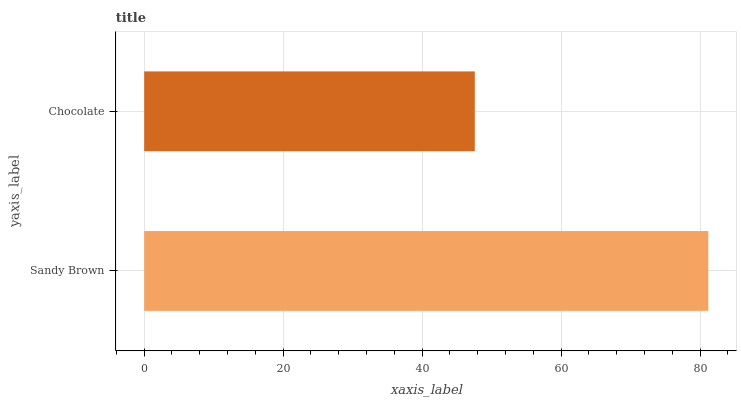Is Chocolate the minimum?
Answer yes or no. Yes. Is Sandy Brown the maximum?
Answer yes or no. Yes. Is Chocolate the maximum?
Answer yes or no. No. Is Sandy Brown greater than Chocolate?
Answer yes or no. Yes. Is Chocolate less than Sandy Brown?
Answer yes or no. Yes. Is Chocolate greater than Sandy Brown?
Answer yes or no. No. Is Sandy Brown less than Chocolate?
Answer yes or no. No. Is Sandy Brown the high median?
Answer yes or no. Yes. Is Chocolate the low median?
Answer yes or no. Yes. Is Chocolate the high median?
Answer yes or no. No. Is Sandy Brown the low median?
Answer yes or no. No. 